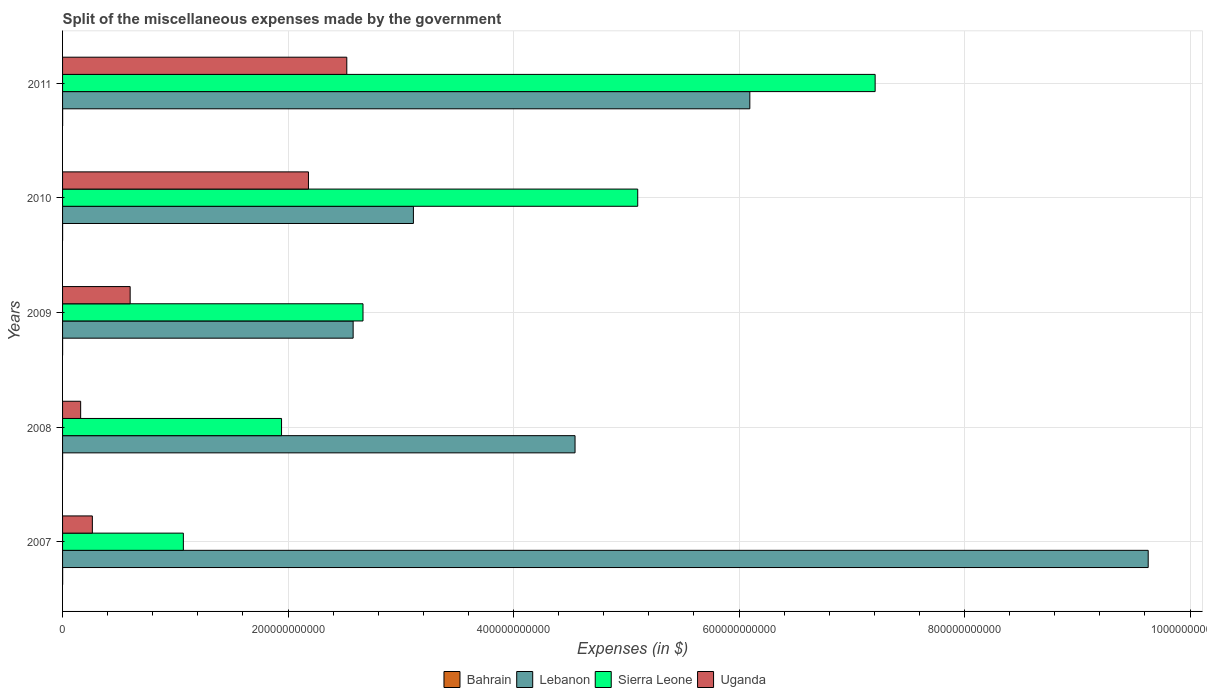How many groups of bars are there?
Keep it short and to the point. 5. How many bars are there on the 1st tick from the top?
Offer a very short reply. 4. How many bars are there on the 1st tick from the bottom?
Your response must be concise. 4. What is the label of the 1st group of bars from the top?
Keep it short and to the point. 2011. In how many cases, is the number of bars for a given year not equal to the number of legend labels?
Keep it short and to the point. 0. What is the miscellaneous expenses made by the government in Lebanon in 2007?
Ensure brevity in your answer.  9.63e+11. Across all years, what is the maximum miscellaneous expenses made by the government in Lebanon?
Offer a terse response. 9.63e+11. Across all years, what is the minimum miscellaneous expenses made by the government in Bahrain?
Provide a short and direct response. 1.90e+07. In which year was the miscellaneous expenses made by the government in Uganda maximum?
Offer a terse response. 2011. What is the total miscellaneous expenses made by the government in Sierra Leone in the graph?
Offer a terse response. 1.80e+12. What is the difference between the miscellaneous expenses made by the government in Bahrain in 2010 and that in 2011?
Your answer should be very brief. -3.32e+07. What is the difference between the miscellaneous expenses made by the government in Lebanon in 2010 and the miscellaneous expenses made by the government in Uganda in 2008?
Your answer should be very brief. 2.95e+11. What is the average miscellaneous expenses made by the government in Sierra Leone per year?
Offer a very short reply. 3.60e+11. In the year 2007, what is the difference between the miscellaneous expenses made by the government in Lebanon and miscellaneous expenses made by the government in Bahrain?
Offer a terse response. 9.63e+11. What is the ratio of the miscellaneous expenses made by the government in Uganda in 2009 to that in 2010?
Offer a terse response. 0.27. What is the difference between the highest and the second highest miscellaneous expenses made by the government in Lebanon?
Provide a succinct answer. 3.53e+11. What is the difference between the highest and the lowest miscellaneous expenses made by the government in Sierra Leone?
Provide a short and direct response. 6.14e+11. What does the 3rd bar from the top in 2011 represents?
Your response must be concise. Lebanon. What does the 2nd bar from the bottom in 2008 represents?
Provide a succinct answer. Lebanon. How many years are there in the graph?
Ensure brevity in your answer.  5. What is the difference between two consecutive major ticks on the X-axis?
Make the answer very short. 2.00e+11. What is the title of the graph?
Your response must be concise. Split of the miscellaneous expenses made by the government. What is the label or title of the X-axis?
Provide a short and direct response. Expenses (in $). What is the label or title of the Y-axis?
Your answer should be very brief. Years. What is the Expenses (in $) in Bahrain in 2007?
Make the answer very short. 5.97e+07. What is the Expenses (in $) in Lebanon in 2007?
Make the answer very short. 9.63e+11. What is the Expenses (in $) in Sierra Leone in 2007?
Your answer should be very brief. 1.07e+11. What is the Expenses (in $) of Uganda in 2007?
Give a very brief answer. 2.64e+1. What is the Expenses (in $) in Bahrain in 2008?
Make the answer very short. 1.90e+07. What is the Expenses (in $) in Lebanon in 2008?
Ensure brevity in your answer.  4.55e+11. What is the Expenses (in $) of Sierra Leone in 2008?
Keep it short and to the point. 1.94e+11. What is the Expenses (in $) of Uganda in 2008?
Give a very brief answer. 1.60e+1. What is the Expenses (in $) of Bahrain in 2009?
Make the answer very short. 2.67e+07. What is the Expenses (in $) of Lebanon in 2009?
Give a very brief answer. 2.58e+11. What is the Expenses (in $) of Sierra Leone in 2009?
Offer a very short reply. 2.66e+11. What is the Expenses (in $) of Uganda in 2009?
Make the answer very short. 6.00e+1. What is the Expenses (in $) of Bahrain in 2010?
Offer a very short reply. 2.50e+07. What is the Expenses (in $) in Lebanon in 2010?
Provide a short and direct response. 3.11e+11. What is the Expenses (in $) of Sierra Leone in 2010?
Ensure brevity in your answer.  5.10e+11. What is the Expenses (in $) of Uganda in 2010?
Provide a succinct answer. 2.18e+11. What is the Expenses (in $) in Bahrain in 2011?
Offer a very short reply. 5.82e+07. What is the Expenses (in $) of Lebanon in 2011?
Your answer should be very brief. 6.10e+11. What is the Expenses (in $) in Sierra Leone in 2011?
Give a very brief answer. 7.21e+11. What is the Expenses (in $) in Uganda in 2011?
Provide a succinct answer. 2.52e+11. Across all years, what is the maximum Expenses (in $) of Bahrain?
Your response must be concise. 5.97e+07. Across all years, what is the maximum Expenses (in $) in Lebanon?
Your answer should be compact. 9.63e+11. Across all years, what is the maximum Expenses (in $) in Sierra Leone?
Your answer should be compact. 7.21e+11. Across all years, what is the maximum Expenses (in $) of Uganda?
Ensure brevity in your answer.  2.52e+11. Across all years, what is the minimum Expenses (in $) in Bahrain?
Ensure brevity in your answer.  1.90e+07. Across all years, what is the minimum Expenses (in $) in Lebanon?
Make the answer very short. 2.58e+11. Across all years, what is the minimum Expenses (in $) of Sierra Leone?
Provide a short and direct response. 1.07e+11. Across all years, what is the minimum Expenses (in $) in Uganda?
Provide a succinct answer. 1.60e+1. What is the total Expenses (in $) of Bahrain in the graph?
Your response must be concise. 1.89e+08. What is the total Expenses (in $) in Lebanon in the graph?
Ensure brevity in your answer.  2.60e+12. What is the total Expenses (in $) of Sierra Leone in the graph?
Your response must be concise. 1.80e+12. What is the total Expenses (in $) of Uganda in the graph?
Provide a short and direct response. 5.73e+11. What is the difference between the Expenses (in $) in Bahrain in 2007 and that in 2008?
Ensure brevity in your answer.  4.07e+07. What is the difference between the Expenses (in $) in Lebanon in 2007 and that in 2008?
Provide a succinct answer. 5.08e+11. What is the difference between the Expenses (in $) of Sierra Leone in 2007 and that in 2008?
Give a very brief answer. -8.71e+1. What is the difference between the Expenses (in $) in Uganda in 2007 and that in 2008?
Your answer should be compact. 1.04e+1. What is the difference between the Expenses (in $) in Bahrain in 2007 and that in 2009?
Ensure brevity in your answer.  3.30e+07. What is the difference between the Expenses (in $) in Lebanon in 2007 and that in 2009?
Keep it short and to the point. 7.05e+11. What is the difference between the Expenses (in $) of Sierra Leone in 2007 and that in 2009?
Offer a terse response. -1.59e+11. What is the difference between the Expenses (in $) of Uganda in 2007 and that in 2009?
Offer a very short reply. -3.35e+1. What is the difference between the Expenses (in $) in Bahrain in 2007 and that in 2010?
Ensure brevity in your answer.  3.47e+07. What is the difference between the Expenses (in $) of Lebanon in 2007 and that in 2010?
Ensure brevity in your answer.  6.52e+11. What is the difference between the Expenses (in $) in Sierra Leone in 2007 and that in 2010?
Your answer should be very brief. -4.03e+11. What is the difference between the Expenses (in $) in Uganda in 2007 and that in 2010?
Your answer should be compact. -1.92e+11. What is the difference between the Expenses (in $) of Bahrain in 2007 and that in 2011?
Provide a succinct answer. 1.48e+06. What is the difference between the Expenses (in $) in Lebanon in 2007 and that in 2011?
Make the answer very short. 3.53e+11. What is the difference between the Expenses (in $) of Sierra Leone in 2007 and that in 2011?
Offer a very short reply. -6.14e+11. What is the difference between the Expenses (in $) of Uganda in 2007 and that in 2011?
Provide a short and direct response. -2.26e+11. What is the difference between the Expenses (in $) in Bahrain in 2008 and that in 2009?
Provide a short and direct response. -7.73e+06. What is the difference between the Expenses (in $) in Lebanon in 2008 and that in 2009?
Provide a succinct answer. 1.97e+11. What is the difference between the Expenses (in $) in Sierra Leone in 2008 and that in 2009?
Provide a succinct answer. -7.22e+1. What is the difference between the Expenses (in $) in Uganda in 2008 and that in 2009?
Your answer should be compact. -4.39e+1. What is the difference between the Expenses (in $) of Bahrain in 2008 and that in 2010?
Keep it short and to the point. -6.02e+06. What is the difference between the Expenses (in $) of Lebanon in 2008 and that in 2010?
Offer a very short reply. 1.43e+11. What is the difference between the Expenses (in $) in Sierra Leone in 2008 and that in 2010?
Make the answer very short. -3.16e+11. What is the difference between the Expenses (in $) of Uganda in 2008 and that in 2010?
Your answer should be very brief. -2.02e+11. What is the difference between the Expenses (in $) in Bahrain in 2008 and that in 2011?
Provide a succinct answer. -3.92e+07. What is the difference between the Expenses (in $) of Lebanon in 2008 and that in 2011?
Your answer should be compact. -1.55e+11. What is the difference between the Expenses (in $) in Sierra Leone in 2008 and that in 2011?
Ensure brevity in your answer.  -5.26e+11. What is the difference between the Expenses (in $) in Uganda in 2008 and that in 2011?
Make the answer very short. -2.36e+11. What is the difference between the Expenses (in $) in Bahrain in 2009 and that in 2010?
Provide a short and direct response. 1.71e+06. What is the difference between the Expenses (in $) of Lebanon in 2009 and that in 2010?
Ensure brevity in your answer.  -5.34e+1. What is the difference between the Expenses (in $) of Sierra Leone in 2009 and that in 2010?
Give a very brief answer. -2.44e+11. What is the difference between the Expenses (in $) of Uganda in 2009 and that in 2010?
Your answer should be very brief. -1.58e+11. What is the difference between the Expenses (in $) in Bahrain in 2009 and that in 2011?
Your answer should be very brief. -3.15e+07. What is the difference between the Expenses (in $) of Lebanon in 2009 and that in 2011?
Ensure brevity in your answer.  -3.52e+11. What is the difference between the Expenses (in $) in Sierra Leone in 2009 and that in 2011?
Give a very brief answer. -4.54e+11. What is the difference between the Expenses (in $) in Uganda in 2009 and that in 2011?
Provide a short and direct response. -1.92e+11. What is the difference between the Expenses (in $) in Bahrain in 2010 and that in 2011?
Your answer should be very brief. -3.32e+07. What is the difference between the Expenses (in $) of Lebanon in 2010 and that in 2011?
Provide a short and direct response. -2.98e+11. What is the difference between the Expenses (in $) in Sierra Leone in 2010 and that in 2011?
Provide a short and direct response. -2.11e+11. What is the difference between the Expenses (in $) of Uganda in 2010 and that in 2011?
Provide a succinct answer. -3.40e+1. What is the difference between the Expenses (in $) in Bahrain in 2007 and the Expenses (in $) in Lebanon in 2008?
Your answer should be very brief. -4.54e+11. What is the difference between the Expenses (in $) in Bahrain in 2007 and the Expenses (in $) in Sierra Leone in 2008?
Provide a short and direct response. -1.94e+11. What is the difference between the Expenses (in $) in Bahrain in 2007 and the Expenses (in $) in Uganda in 2008?
Your answer should be compact. -1.60e+1. What is the difference between the Expenses (in $) in Lebanon in 2007 and the Expenses (in $) in Sierra Leone in 2008?
Provide a short and direct response. 7.69e+11. What is the difference between the Expenses (in $) in Lebanon in 2007 and the Expenses (in $) in Uganda in 2008?
Your answer should be compact. 9.47e+11. What is the difference between the Expenses (in $) of Sierra Leone in 2007 and the Expenses (in $) of Uganda in 2008?
Keep it short and to the point. 9.11e+1. What is the difference between the Expenses (in $) in Bahrain in 2007 and the Expenses (in $) in Lebanon in 2009?
Offer a very short reply. -2.58e+11. What is the difference between the Expenses (in $) in Bahrain in 2007 and the Expenses (in $) in Sierra Leone in 2009?
Your answer should be very brief. -2.66e+11. What is the difference between the Expenses (in $) of Bahrain in 2007 and the Expenses (in $) of Uganda in 2009?
Ensure brevity in your answer.  -5.99e+1. What is the difference between the Expenses (in $) of Lebanon in 2007 and the Expenses (in $) of Sierra Leone in 2009?
Ensure brevity in your answer.  6.96e+11. What is the difference between the Expenses (in $) in Lebanon in 2007 and the Expenses (in $) in Uganda in 2009?
Offer a terse response. 9.03e+11. What is the difference between the Expenses (in $) of Sierra Leone in 2007 and the Expenses (in $) of Uganda in 2009?
Give a very brief answer. 4.72e+1. What is the difference between the Expenses (in $) in Bahrain in 2007 and the Expenses (in $) in Lebanon in 2010?
Offer a very short reply. -3.11e+11. What is the difference between the Expenses (in $) in Bahrain in 2007 and the Expenses (in $) in Sierra Leone in 2010?
Ensure brevity in your answer.  -5.10e+11. What is the difference between the Expenses (in $) in Bahrain in 2007 and the Expenses (in $) in Uganda in 2010?
Your response must be concise. -2.18e+11. What is the difference between the Expenses (in $) of Lebanon in 2007 and the Expenses (in $) of Sierra Leone in 2010?
Keep it short and to the point. 4.53e+11. What is the difference between the Expenses (in $) of Lebanon in 2007 and the Expenses (in $) of Uganda in 2010?
Provide a short and direct response. 7.45e+11. What is the difference between the Expenses (in $) of Sierra Leone in 2007 and the Expenses (in $) of Uganda in 2010?
Your response must be concise. -1.11e+11. What is the difference between the Expenses (in $) in Bahrain in 2007 and the Expenses (in $) in Lebanon in 2011?
Provide a short and direct response. -6.09e+11. What is the difference between the Expenses (in $) in Bahrain in 2007 and the Expenses (in $) in Sierra Leone in 2011?
Keep it short and to the point. -7.21e+11. What is the difference between the Expenses (in $) of Bahrain in 2007 and the Expenses (in $) of Uganda in 2011?
Your response must be concise. -2.52e+11. What is the difference between the Expenses (in $) in Lebanon in 2007 and the Expenses (in $) in Sierra Leone in 2011?
Your answer should be very brief. 2.42e+11. What is the difference between the Expenses (in $) of Lebanon in 2007 and the Expenses (in $) of Uganda in 2011?
Give a very brief answer. 7.11e+11. What is the difference between the Expenses (in $) of Sierra Leone in 2007 and the Expenses (in $) of Uganda in 2011?
Provide a short and direct response. -1.45e+11. What is the difference between the Expenses (in $) of Bahrain in 2008 and the Expenses (in $) of Lebanon in 2009?
Ensure brevity in your answer.  -2.58e+11. What is the difference between the Expenses (in $) in Bahrain in 2008 and the Expenses (in $) in Sierra Leone in 2009?
Offer a terse response. -2.66e+11. What is the difference between the Expenses (in $) of Bahrain in 2008 and the Expenses (in $) of Uganda in 2009?
Keep it short and to the point. -5.99e+1. What is the difference between the Expenses (in $) of Lebanon in 2008 and the Expenses (in $) of Sierra Leone in 2009?
Provide a short and direct response. 1.88e+11. What is the difference between the Expenses (in $) of Lebanon in 2008 and the Expenses (in $) of Uganda in 2009?
Your answer should be very brief. 3.95e+11. What is the difference between the Expenses (in $) in Sierra Leone in 2008 and the Expenses (in $) in Uganda in 2009?
Offer a terse response. 1.34e+11. What is the difference between the Expenses (in $) of Bahrain in 2008 and the Expenses (in $) of Lebanon in 2010?
Provide a succinct answer. -3.11e+11. What is the difference between the Expenses (in $) in Bahrain in 2008 and the Expenses (in $) in Sierra Leone in 2010?
Provide a succinct answer. -5.10e+11. What is the difference between the Expenses (in $) in Bahrain in 2008 and the Expenses (in $) in Uganda in 2010?
Your answer should be very brief. -2.18e+11. What is the difference between the Expenses (in $) in Lebanon in 2008 and the Expenses (in $) in Sierra Leone in 2010?
Give a very brief answer. -5.56e+1. What is the difference between the Expenses (in $) of Lebanon in 2008 and the Expenses (in $) of Uganda in 2010?
Make the answer very short. 2.36e+11. What is the difference between the Expenses (in $) of Sierra Leone in 2008 and the Expenses (in $) of Uganda in 2010?
Provide a succinct answer. -2.39e+1. What is the difference between the Expenses (in $) in Bahrain in 2008 and the Expenses (in $) in Lebanon in 2011?
Keep it short and to the point. -6.10e+11. What is the difference between the Expenses (in $) in Bahrain in 2008 and the Expenses (in $) in Sierra Leone in 2011?
Provide a succinct answer. -7.21e+11. What is the difference between the Expenses (in $) of Bahrain in 2008 and the Expenses (in $) of Uganda in 2011?
Offer a terse response. -2.52e+11. What is the difference between the Expenses (in $) of Lebanon in 2008 and the Expenses (in $) of Sierra Leone in 2011?
Give a very brief answer. -2.66e+11. What is the difference between the Expenses (in $) in Lebanon in 2008 and the Expenses (in $) in Uganda in 2011?
Provide a short and direct response. 2.02e+11. What is the difference between the Expenses (in $) of Sierra Leone in 2008 and the Expenses (in $) of Uganda in 2011?
Your answer should be compact. -5.79e+1. What is the difference between the Expenses (in $) in Bahrain in 2009 and the Expenses (in $) in Lebanon in 2010?
Offer a terse response. -3.11e+11. What is the difference between the Expenses (in $) of Bahrain in 2009 and the Expenses (in $) of Sierra Leone in 2010?
Your response must be concise. -5.10e+11. What is the difference between the Expenses (in $) of Bahrain in 2009 and the Expenses (in $) of Uganda in 2010?
Give a very brief answer. -2.18e+11. What is the difference between the Expenses (in $) in Lebanon in 2009 and the Expenses (in $) in Sierra Leone in 2010?
Your answer should be very brief. -2.52e+11. What is the difference between the Expenses (in $) in Lebanon in 2009 and the Expenses (in $) in Uganda in 2010?
Give a very brief answer. 3.96e+1. What is the difference between the Expenses (in $) of Sierra Leone in 2009 and the Expenses (in $) of Uganda in 2010?
Provide a succinct answer. 4.84e+1. What is the difference between the Expenses (in $) of Bahrain in 2009 and the Expenses (in $) of Lebanon in 2011?
Give a very brief answer. -6.10e+11. What is the difference between the Expenses (in $) of Bahrain in 2009 and the Expenses (in $) of Sierra Leone in 2011?
Ensure brevity in your answer.  -7.21e+11. What is the difference between the Expenses (in $) in Bahrain in 2009 and the Expenses (in $) in Uganda in 2011?
Your answer should be compact. -2.52e+11. What is the difference between the Expenses (in $) in Lebanon in 2009 and the Expenses (in $) in Sierra Leone in 2011?
Your response must be concise. -4.63e+11. What is the difference between the Expenses (in $) in Lebanon in 2009 and the Expenses (in $) in Uganda in 2011?
Your answer should be very brief. 5.63e+09. What is the difference between the Expenses (in $) of Sierra Leone in 2009 and the Expenses (in $) of Uganda in 2011?
Provide a succinct answer. 1.44e+1. What is the difference between the Expenses (in $) in Bahrain in 2010 and the Expenses (in $) in Lebanon in 2011?
Your answer should be compact. -6.10e+11. What is the difference between the Expenses (in $) in Bahrain in 2010 and the Expenses (in $) in Sierra Leone in 2011?
Offer a terse response. -7.21e+11. What is the difference between the Expenses (in $) in Bahrain in 2010 and the Expenses (in $) in Uganda in 2011?
Offer a very short reply. -2.52e+11. What is the difference between the Expenses (in $) in Lebanon in 2010 and the Expenses (in $) in Sierra Leone in 2011?
Offer a very short reply. -4.10e+11. What is the difference between the Expenses (in $) of Lebanon in 2010 and the Expenses (in $) of Uganda in 2011?
Your answer should be very brief. 5.91e+1. What is the difference between the Expenses (in $) in Sierra Leone in 2010 and the Expenses (in $) in Uganda in 2011?
Give a very brief answer. 2.58e+11. What is the average Expenses (in $) of Bahrain per year?
Offer a terse response. 3.77e+07. What is the average Expenses (in $) in Lebanon per year?
Your answer should be compact. 5.19e+11. What is the average Expenses (in $) in Sierra Leone per year?
Your answer should be very brief. 3.60e+11. What is the average Expenses (in $) in Uganda per year?
Make the answer very short. 1.15e+11. In the year 2007, what is the difference between the Expenses (in $) in Bahrain and Expenses (in $) in Lebanon?
Give a very brief answer. -9.63e+11. In the year 2007, what is the difference between the Expenses (in $) in Bahrain and Expenses (in $) in Sierra Leone?
Offer a terse response. -1.07e+11. In the year 2007, what is the difference between the Expenses (in $) of Bahrain and Expenses (in $) of Uganda?
Give a very brief answer. -2.64e+1. In the year 2007, what is the difference between the Expenses (in $) in Lebanon and Expenses (in $) in Sierra Leone?
Your answer should be very brief. 8.56e+11. In the year 2007, what is the difference between the Expenses (in $) of Lebanon and Expenses (in $) of Uganda?
Offer a terse response. 9.36e+11. In the year 2007, what is the difference between the Expenses (in $) in Sierra Leone and Expenses (in $) in Uganda?
Keep it short and to the point. 8.07e+1. In the year 2008, what is the difference between the Expenses (in $) of Bahrain and Expenses (in $) of Lebanon?
Make the answer very short. -4.55e+11. In the year 2008, what is the difference between the Expenses (in $) of Bahrain and Expenses (in $) of Sierra Leone?
Your answer should be very brief. -1.94e+11. In the year 2008, what is the difference between the Expenses (in $) in Bahrain and Expenses (in $) in Uganda?
Make the answer very short. -1.60e+1. In the year 2008, what is the difference between the Expenses (in $) in Lebanon and Expenses (in $) in Sierra Leone?
Provide a succinct answer. 2.60e+11. In the year 2008, what is the difference between the Expenses (in $) of Lebanon and Expenses (in $) of Uganda?
Your answer should be very brief. 4.38e+11. In the year 2008, what is the difference between the Expenses (in $) of Sierra Leone and Expenses (in $) of Uganda?
Keep it short and to the point. 1.78e+11. In the year 2009, what is the difference between the Expenses (in $) of Bahrain and Expenses (in $) of Lebanon?
Your answer should be very brief. -2.58e+11. In the year 2009, what is the difference between the Expenses (in $) in Bahrain and Expenses (in $) in Sierra Leone?
Provide a short and direct response. -2.66e+11. In the year 2009, what is the difference between the Expenses (in $) of Bahrain and Expenses (in $) of Uganda?
Provide a succinct answer. -5.99e+1. In the year 2009, what is the difference between the Expenses (in $) of Lebanon and Expenses (in $) of Sierra Leone?
Keep it short and to the point. -8.74e+09. In the year 2009, what is the difference between the Expenses (in $) of Lebanon and Expenses (in $) of Uganda?
Provide a short and direct response. 1.98e+11. In the year 2009, what is the difference between the Expenses (in $) of Sierra Leone and Expenses (in $) of Uganda?
Keep it short and to the point. 2.07e+11. In the year 2010, what is the difference between the Expenses (in $) in Bahrain and Expenses (in $) in Lebanon?
Provide a short and direct response. -3.11e+11. In the year 2010, what is the difference between the Expenses (in $) of Bahrain and Expenses (in $) of Sierra Leone?
Give a very brief answer. -5.10e+11. In the year 2010, what is the difference between the Expenses (in $) of Bahrain and Expenses (in $) of Uganda?
Keep it short and to the point. -2.18e+11. In the year 2010, what is the difference between the Expenses (in $) of Lebanon and Expenses (in $) of Sierra Leone?
Make the answer very short. -1.99e+11. In the year 2010, what is the difference between the Expenses (in $) in Lebanon and Expenses (in $) in Uganda?
Provide a short and direct response. 9.31e+1. In the year 2010, what is the difference between the Expenses (in $) in Sierra Leone and Expenses (in $) in Uganda?
Your answer should be very brief. 2.92e+11. In the year 2011, what is the difference between the Expenses (in $) in Bahrain and Expenses (in $) in Lebanon?
Your answer should be very brief. -6.09e+11. In the year 2011, what is the difference between the Expenses (in $) of Bahrain and Expenses (in $) of Sierra Leone?
Keep it short and to the point. -7.21e+11. In the year 2011, what is the difference between the Expenses (in $) in Bahrain and Expenses (in $) in Uganda?
Your answer should be compact. -2.52e+11. In the year 2011, what is the difference between the Expenses (in $) of Lebanon and Expenses (in $) of Sierra Leone?
Provide a short and direct response. -1.11e+11. In the year 2011, what is the difference between the Expenses (in $) in Lebanon and Expenses (in $) in Uganda?
Your response must be concise. 3.57e+11. In the year 2011, what is the difference between the Expenses (in $) in Sierra Leone and Expenses (in $) in Uganda?
Give a very brief answer. 4.69e+11. What is the ratio of the Expenses (in $) of Bahrain in 2007 to that in 2008?
Offer a terse response. 3.15. What is the ratio of the Expenses (in $) of Lebanon in 2007 to that in 2008?
Make the answer very short. 2.12. What is the ratio of the Expenses (in $) in Sierra Leone in 2007 to that in 2008?
Offer a terse response. 0.55. What is the ratio of the Expenses (in $) of Uganda in 2007 to that in 2008?
Keep it short and to the point. 1.65. What is the ratio of the Expenses (in $) of Bahrain in 2007 to that in 2009?
Keep it short and to the point. 2.24. What is the ratio of the Expenses (in $) of Lebanon in 2007 to that in 2009?
Offer a terse response. 3.74. What is the ratio of the Expenses (in $) of Sierra Leone in 2007 to that in 2009?
Keep it short and to the point. 0.4. What is the ratio of the Expenses (in $) of Uganda in 2007 to that in 2009?
Your answer should be very brief. 0.44. What is the ratio of the Expenses (in $) in Bahrain in 2007 to that in 2010?
Give a very brief answer. 2.39. What is the ratio of the Expenses (in $) in Lebanon in 2007 to that in 2010?
Keep it short and to the point. 3.09. What is the ratio of the Expenses (in $) of Sierra Leone in 2007 to that in 2010?
Your answer should be compact. 0.21. What is the ratio of the Expenses (in $) in Uganda in 2007 to that in 2010?
Provide a succinct answer. 0.12. What is the ratio of the Expenses (in $) in Bahrain in 2007 to that in 2011?
Provide a short and direct response. 1.03. What is the ratio of the Expenses (in $) in Lebanon in 2007 to that in 2011?
Give a very brief answer. 1.58. What is the ratio of the Expenses (in $) of Sierra Leone in 2007 to that in 2011?
Ensure brevity in your answer.  0.15. What is the ratio of the Expenses (in $) in Uganda in 2007 to that in 2011?
Offer a terse response. 0.1. What is the ratio of the Expenses (in $) of Bahrain in 2008 to that in 2009?
Offer a terse response. 0.71. What is the ratio of the Expenses (in $) of Lebanon in 2008 to that in 2009?
Your response must be concise. 1.76. What is the ratio of the Expenses (in $) in Sierra Leone in 2008 to that in 2009?
Your answer should be compact. 0.73. What is the ratio of the Expenses (in $) of Uganda in 2008 to that in 2009?
Offer a terse response. 0.27. What is the ratio of the Expenses (in $) of Bahrain in 2008 to that in 2010?
Your response must be concise. 0.76. What is the ratio of the Expenses (in $) of Lebanon in 2008 to that in 2010?
Offer a very short reply. 1.46. What is the ratio of the Expenses (in $) in Sierra Leone in 2008 to that in 2010?
Your response must be concise. 0.38. What is the ratio of the Expenses (in $) in Uganda in 2008 to that in 2010?
Your answer should be compact. 0.07. What is the ratio of the Expenses (in $) of Bahrain in 2008 to that in 2011?
Give a very brief answer. 0.33. What is the ratio of the Expenses (in $) of Lebanon in 2008 to that in 2011?
Provide a short and direct response. 0.75. What is the ratio of the Expenses (in $) of Sierra Leone in 2008 to that in 2011?
Provide a succinct answer. 0.27. What is the ratio of the Expenses (in $) in Uganda in 2008 to that in 2011?
Your answer should be compact. 0.06. What is the ratio of the Expenses (in $) in Bahrain in 2009 to that in 2010?
Offer a terse response. 1.07. What is the ratio of the Expenses (in $) in Lebanon in 2009 to that in 2010?
Ensure brevity in your answer.  0.83. What is the ratio of the Expenses (in $) in Sierra Leone in 2009 to that in 2010?
Your answer should be very brief. 0.52. What is the ratio of the Expenses (in $) in Uganda in 2009 to that in 2010?
Provide a short and direct response. 0.27. What is the ratio of the Expenses (in $) of Bahrain in 2009 to that in 2011?
Provide a succinct answer. 0.46. What is the ratio of the Expenses (in $) of Lebanon in 2009 to that in 2011?
Make the answer very short. 0.42. What is the ratio of the Expenses (in $) in Sierra Leone in 2009 to that in 2011?
Offer a terse response. 0.37. What is the ratio of the Expenses (in $) of Uganda in 2009 to that in 2011?
Your response must be concise. 0.24. What is the ratio of the Expenses (in $) in Bahrain in 2010 to that in 2011?
Keep it short and to the point. 0.43. What is the ratio of the Expenses (in $) in Lebanon in 2010 to that in 2011?
Offer a terse response. 0.51. What is the ratio of the Expenses (in $) in Sierra Leone in 2010 to that in 2011?
Offer a terse response. 0.71. What is the ratio of the Expenses (in $) of Uganda in 2010 to that in 2011?
Give a very brief answer. 0.87. What is the difference between the highest and the second highest Expenses (in $) of Bahrain?
Your answer should be compact. 1.48e+06. What is the difference between the highest and the second highest Expenses (in $) in Lebanon?
Offer a very short reply. 3.53e+11. What is the difference between the highest and the second highest Expenses (in $) of Sierra Leone?
Give a very brief answer. 2.11e+11. What is the difference between the highest and the second highest Expenses (in $) of Uganda?
Your answer should be compact. 3.40e+1. What is the difference between the highest and the lowest Expenses (in $) in Bahrain?
Offer a very short reply. 4.07e+07. What is the difference between the highest and the lowest Expenses (in $) in Lebanon?
Provide a short and direct response. 7.05e+11. What is the difference between the highest and the lowest Expenses (in $) in Sierra Leone?
Provide a short and direct response. 6.14e+11. What is the difference between the highest and the lowest Expenses (in $) of Uganda?
Your response must be concise. 2.36e+11. 